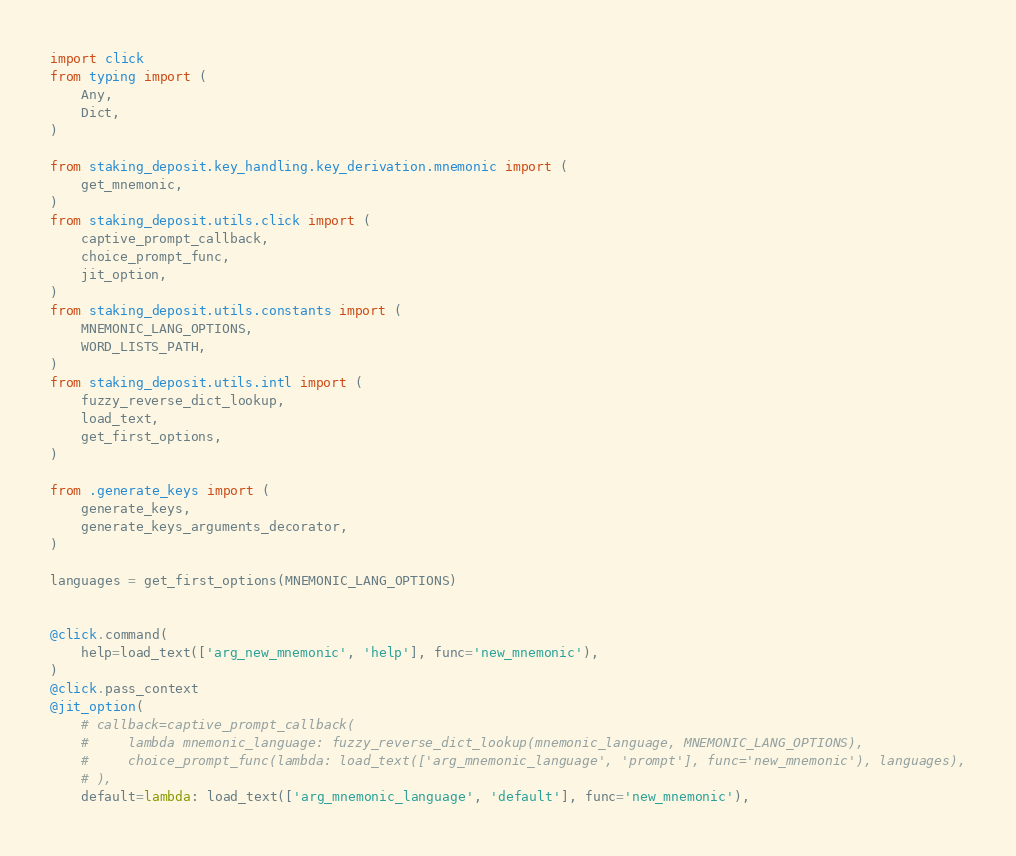Convert code to text. <code><loc_0><loc_0><loc_500><loc_500><_Python_>import click
from typing import (
    Any,
    Dict,
)

from staking_deposit.key_handling.key_derivation.mnemonic import (
    get_mnemonic,
)
from staking_deposit.utils.click import (
    captive_prompt_callback,
    choice_prompt_func,
    jit_option,
)
from staking_deposit.utils.constants import (
    MNEMONIC_LANG_OPTIONS,
    WORD_LISTS_PATH,
)
from staking_deposit.utils.intl import (
    fuzzy_reverse_dict_lookup,
    load_text,
    get_first_options,
)

from .generate_keys import (
    generate_keys,
    generate_keys_arguments_decorator,
)

languages = get_first_options(MNEMONIC_LANG_OPTIONS)


@click.command(
    help=load_text(['arg_new_mnemonic', 'help'], func='new_mnemonic'),
)
@click.pass_context
@jit_option(
    # callback=captive_prompt_callback(
    #     lambda mnemonic_language: fuzzy_reverse_dict_lookup(mnemonic_language, MNEMONIC_LANG_OPTIONS),
    #     choice_prompt_func(lambda: load_text(['arg_mnemonic_language', 'prompt'], func='new_mnemonic'), languages),
    # ),
    default=lambda: load_text(['arg_mnemonic_language', 'default'], func='new_mnemonic'),</code> 